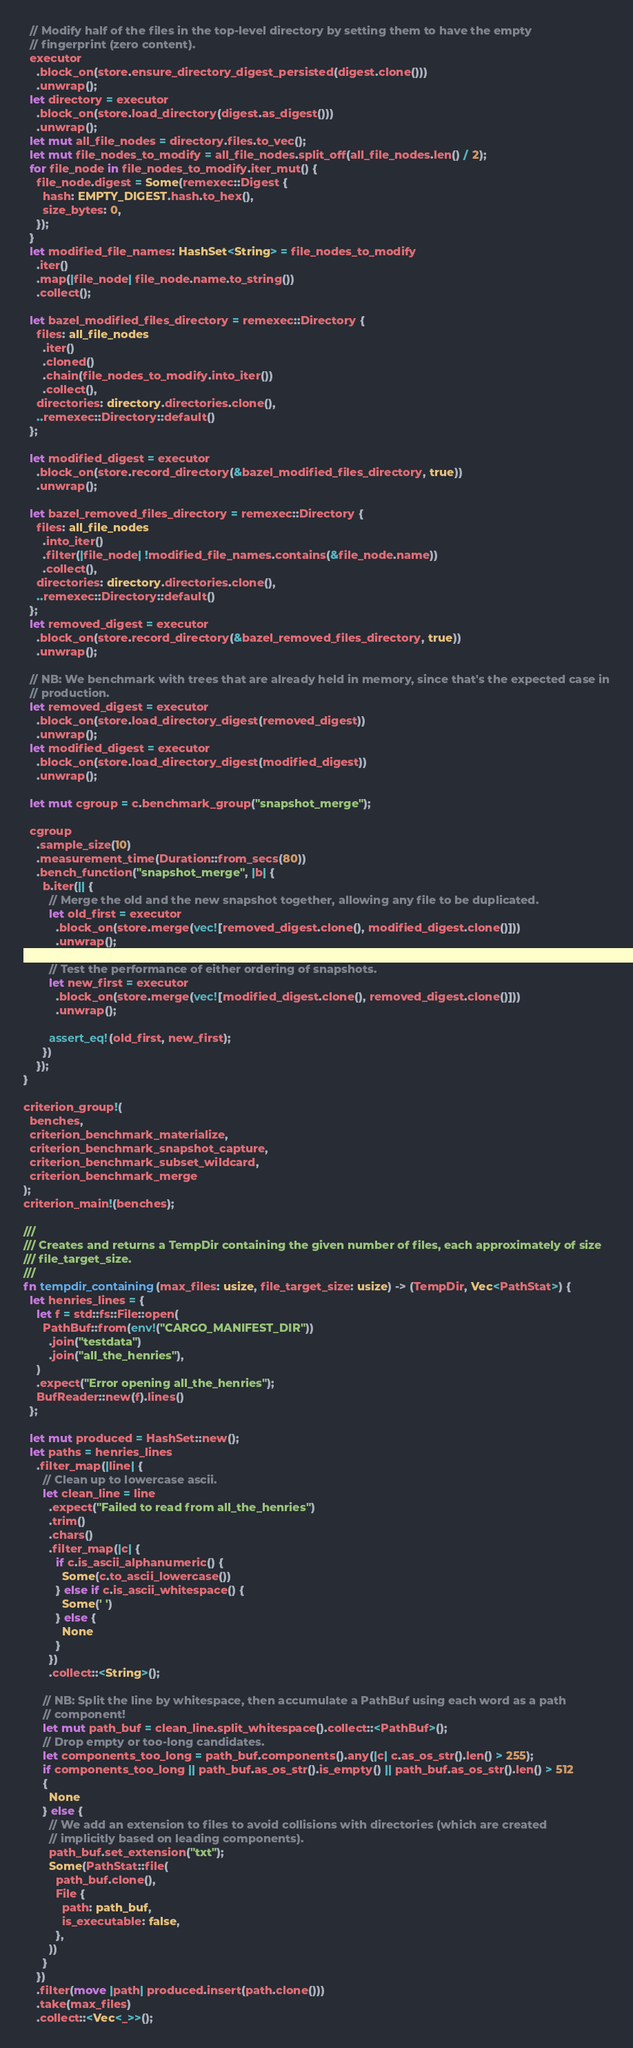Convert code to text. <code><loc_0><loc_0><loc_500><loc_500><_Rust_>  // Modify half of the files in the top-level directory by setting them to have the empty
  // fingerprint (zero content).
  executor
    .block_on(store.ensure_directory_digest_persisted(digest.clone()))
    .unwrap();
  let directory = executor
    .block_on(store.load_directory(digest.as_digest()))
    .unwrap();
  let mut all_file_nodes = directory.files.to_vec();
  let mut file_nodes_to_modify = all_file_nodes.split_off(all_file_nodes.len() / 2);
  for file_node in file_nodes_to_modify.iter_mut() {
    file_node.digest = Some(remexec::Digest {
      hash: EMPTY_DIGEST.hash.to_hex(),
      size_bytes: 0,
    });
  }
  let modified_file_names: HashSet<String> = file_nodes_to_modify
    .iter()
    .map(|file_node| file_node.name.to_string())
    .collect();

  let bazel_modified_files_directory = remexec::Directory {
    files: all_file_nodes
      .iter()
      .cloned()
      .chain(file_nodes_to_modify.into_iter())
      .collect(),
    directories: directory.directories.clone(),
    ..remexec::Directory::default()
  };

  let modified_digest = executor
    .block_on(store.record_directory(&bazel_modified_files_directory, true))
    .unwrap();

  let bazel_removed_files_directory = remexec::Directory {
    files: all_file_nodes
      .into_iter()
      .filter(|file_node| !modified_file_names.contains(&file_node.name))
      .collect(),
    directories: directory.directories.clone(),
    ..remexec::Directory::default()
  };
  let removed_digest = executor
    .block_on(store.record_directory(&bazel_removed_files_directory, true))
    .unwrap();

  // NB: We benchmark with trees that are already held in memory, since that's the expected case in
  // production.
  let removed_digest = executor
    .block_on(store.load_directory_digest(removed_digest))
    .unwrap();
  let modified_digest = executor
    .block_on(store.load_directory_digest(modified_digest))
    .unwrap();

  let mut cgroup = c.benchmark_group("snapshot_merge");

  cgroup
    .sample_size(10)
    .measurement_time(Duration::from_secs(80))
    .bench_function("snapshot_merge", |b| {
      b.iter(|| {
        // Merge the old and the new snapshot together, allowing any file to be duplicated.
        let old_first = executor
          .block_on(store.merge(vec![removed_digest.clone(), modified_digest.clone()]))
          .unwrap();

        // Test the performance of either ordering of snapshots.
        let new_first = executor
          .block_on(store.merge(vec![modified_digest.clone(), removed_digest.clone()]))
          .unwrap();

        assert_eq!(old_first, new_first);
      })
    });
}

criterion_group!(
  benches,
  criterion_benchmark_materialize,
  criterion_benchmark_snapshot_capture,
  criterion_benchmark_subset_wildcard,
  criterion_benchmark_merge
);
criterion_main!(benches);

///
/// Creates and returns a TempDir containing the given number of files, each approximately of size
/// file_target_size.
///
fn tempdir_containing(max_files: usize, file_target_size: usize) -> (TempDir, Vec<PathStat>) {
  let henries_lines = {
    let f = std::fs::File::open(
      PathBuf::from(env!("CARGO_MANIFEST_DIR"))
        .join("testdata")
        .join("all_the_henries"),
    )
    .expect("Error opening all_the_henries");
    BufReader::new(f).lines()
  };

  let mut produced = HashSet::new();
  let paths = henries_lines
    .filter_map(|line| {
      // Clean up to lowercase ascii.
      let clean_line = line
        .expect("Failed to read from all_the_henries")
        .trim()
        .chars()
        .filter_map(|c| {
          if c.is_ascii_alphanumeric() {
            Some(c.to_ascii_lowercase())
          } else if c.is_ascii_whitespace() {
            Some(' ')
          } else {
            None
          }
        })
        .collect::<String>();

      // NB: Split the line by whitespace, then accumulate a PathBuf using each word as a path
      // component!
      let mut path_buf = clean_line.split_whitespace().collect::<PathBuf>();
      // Drop empty or too-long candidates.
      let components_too_long = path_buf.components().any(|c| c.as_os_str().len() > 255);
      if components_too_long || path_buf.as_os_str().is_empty() || path_buf.as_os_str().len() > 512
      {
        None
      } else {
        // We add an extension to files to avoid collisions with directories (which are created
        // implicitly based on leading components).
        path_buf.set_extension("txt");
        Some(PathStat::file(
          path_buf.clone(),
          File {
            path: path_buf,
            is_executable: false,
          },
        ))
      }
    })
    .filter(move |path| produced.insert(path.clone()))
    .take(max_files)
    .collect::<Vec<_>>();
</code> 